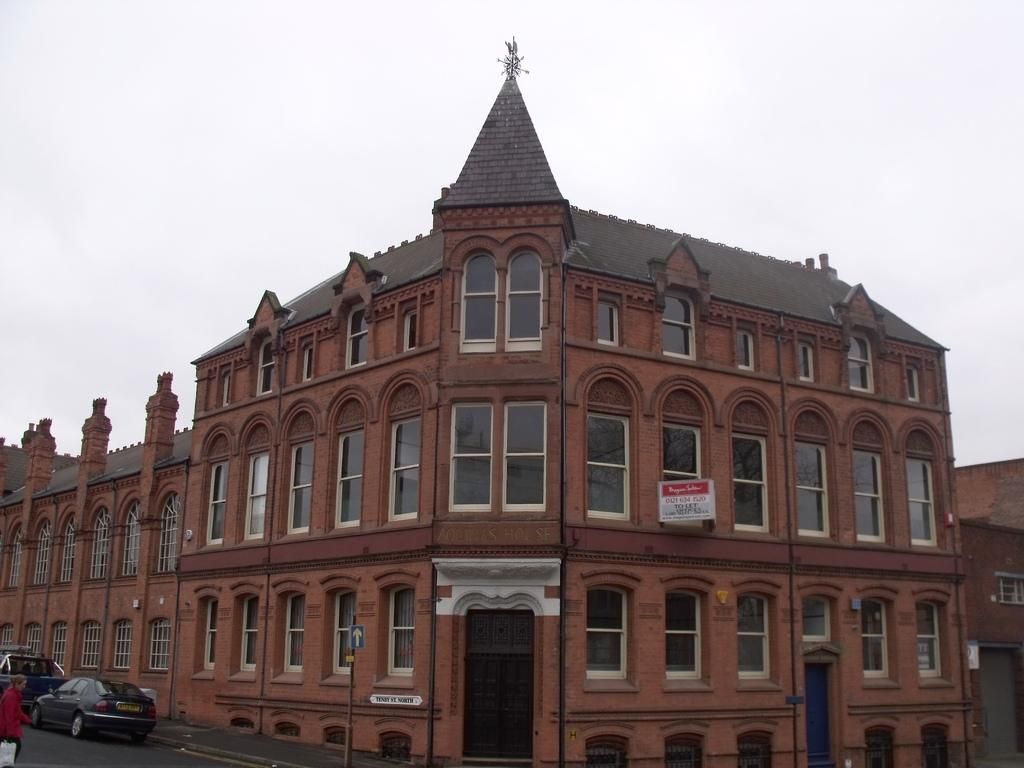What type of structures can be seen in the image? There are buildings in the image. What else can be seen in the image besides the buildings? There are boards, a pole, vehicles on the road, and a person holding a bag in the image. Where is the person holding the bag located in the image? The person holding the bag is in the image. What is visible at the top of the image? The sky is visible at the top of the image. What type of competition is taking place between the buildings in the image? There is no competition between the buildings in the image; they are simply structures. Can you spot a snake slithering through the image? There is no snake present in the image. 